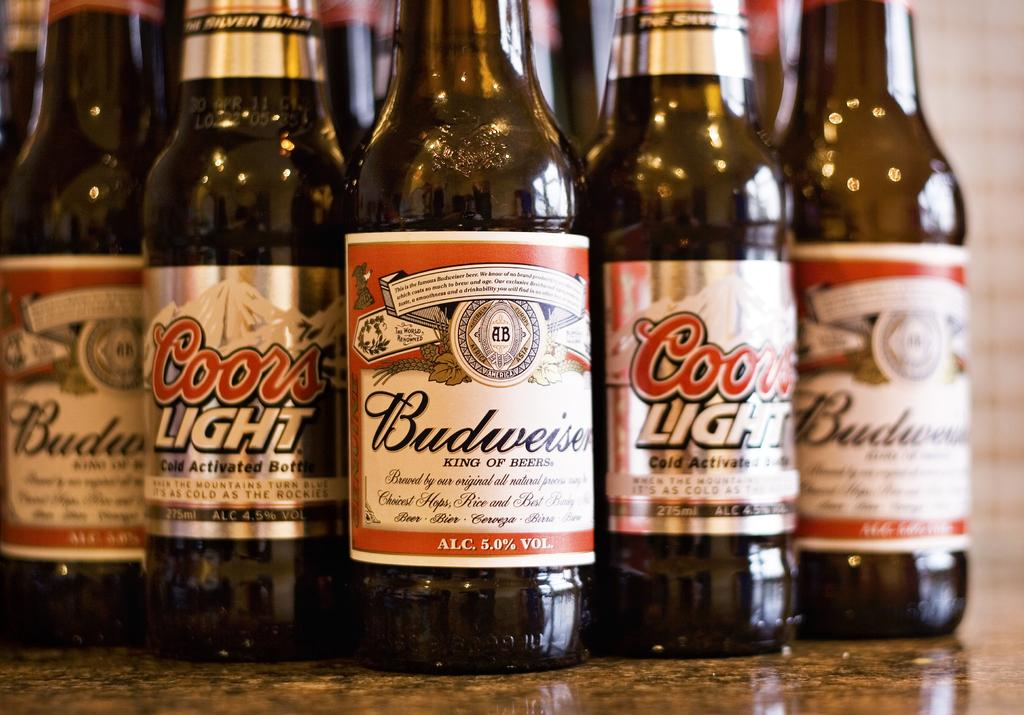<image>
Create a compact narrative representing the image presented. Bottles of Budweiser and Coors Light are arranged on a table. 